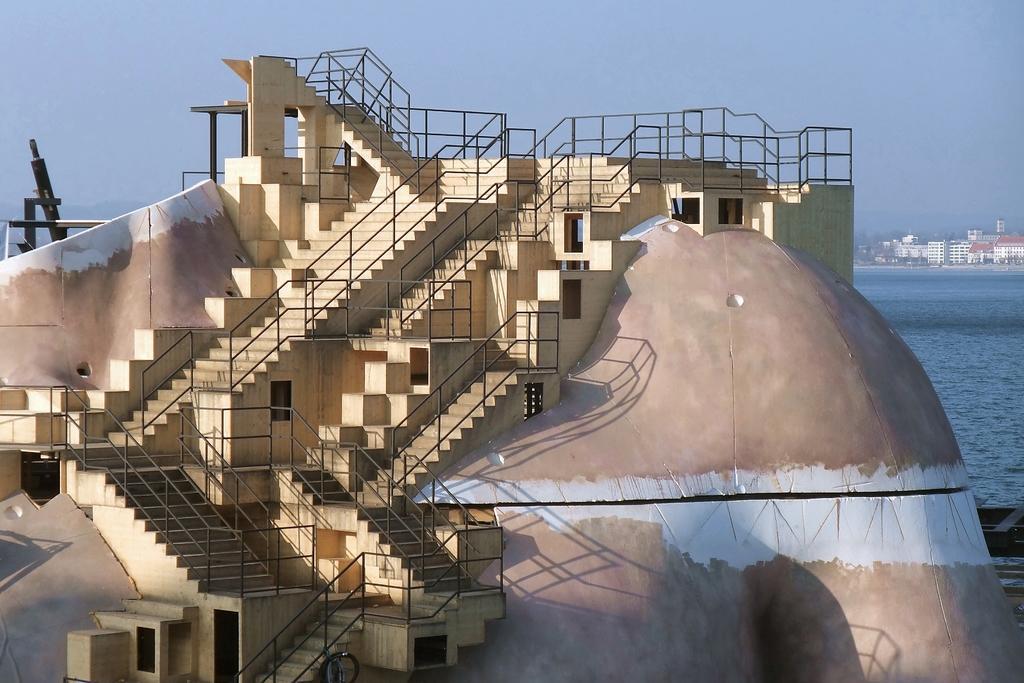Can you describe this image briefly? In this image we can see some concrete structure with the stairs and also railing. In the background we can see the sea, buildings and also the sky. 